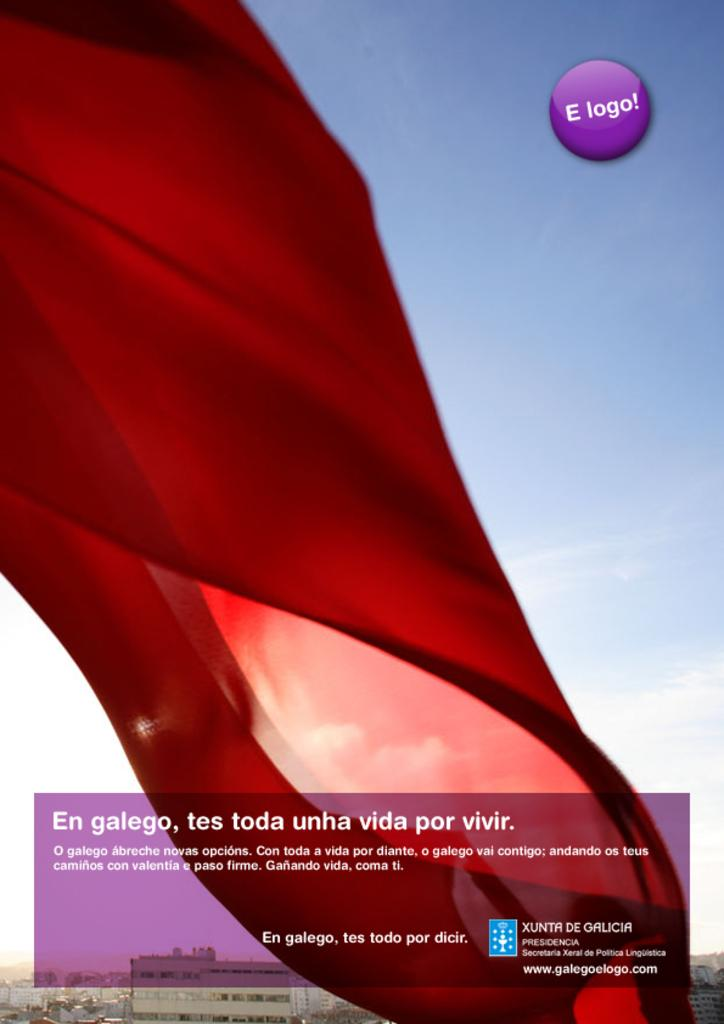<image>
Present a compact description of the photo's key features. a large red curtain with an E logo sign next to it 